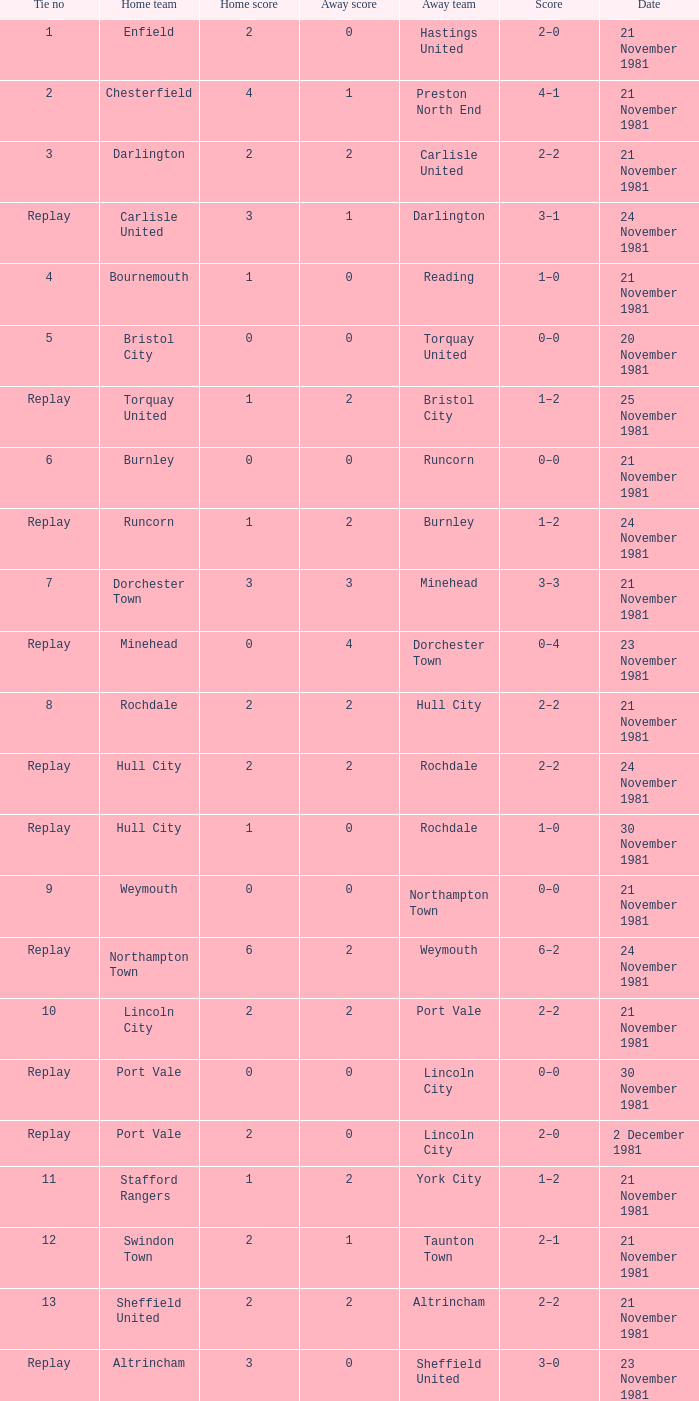Minehead has what tie number? Replay. 